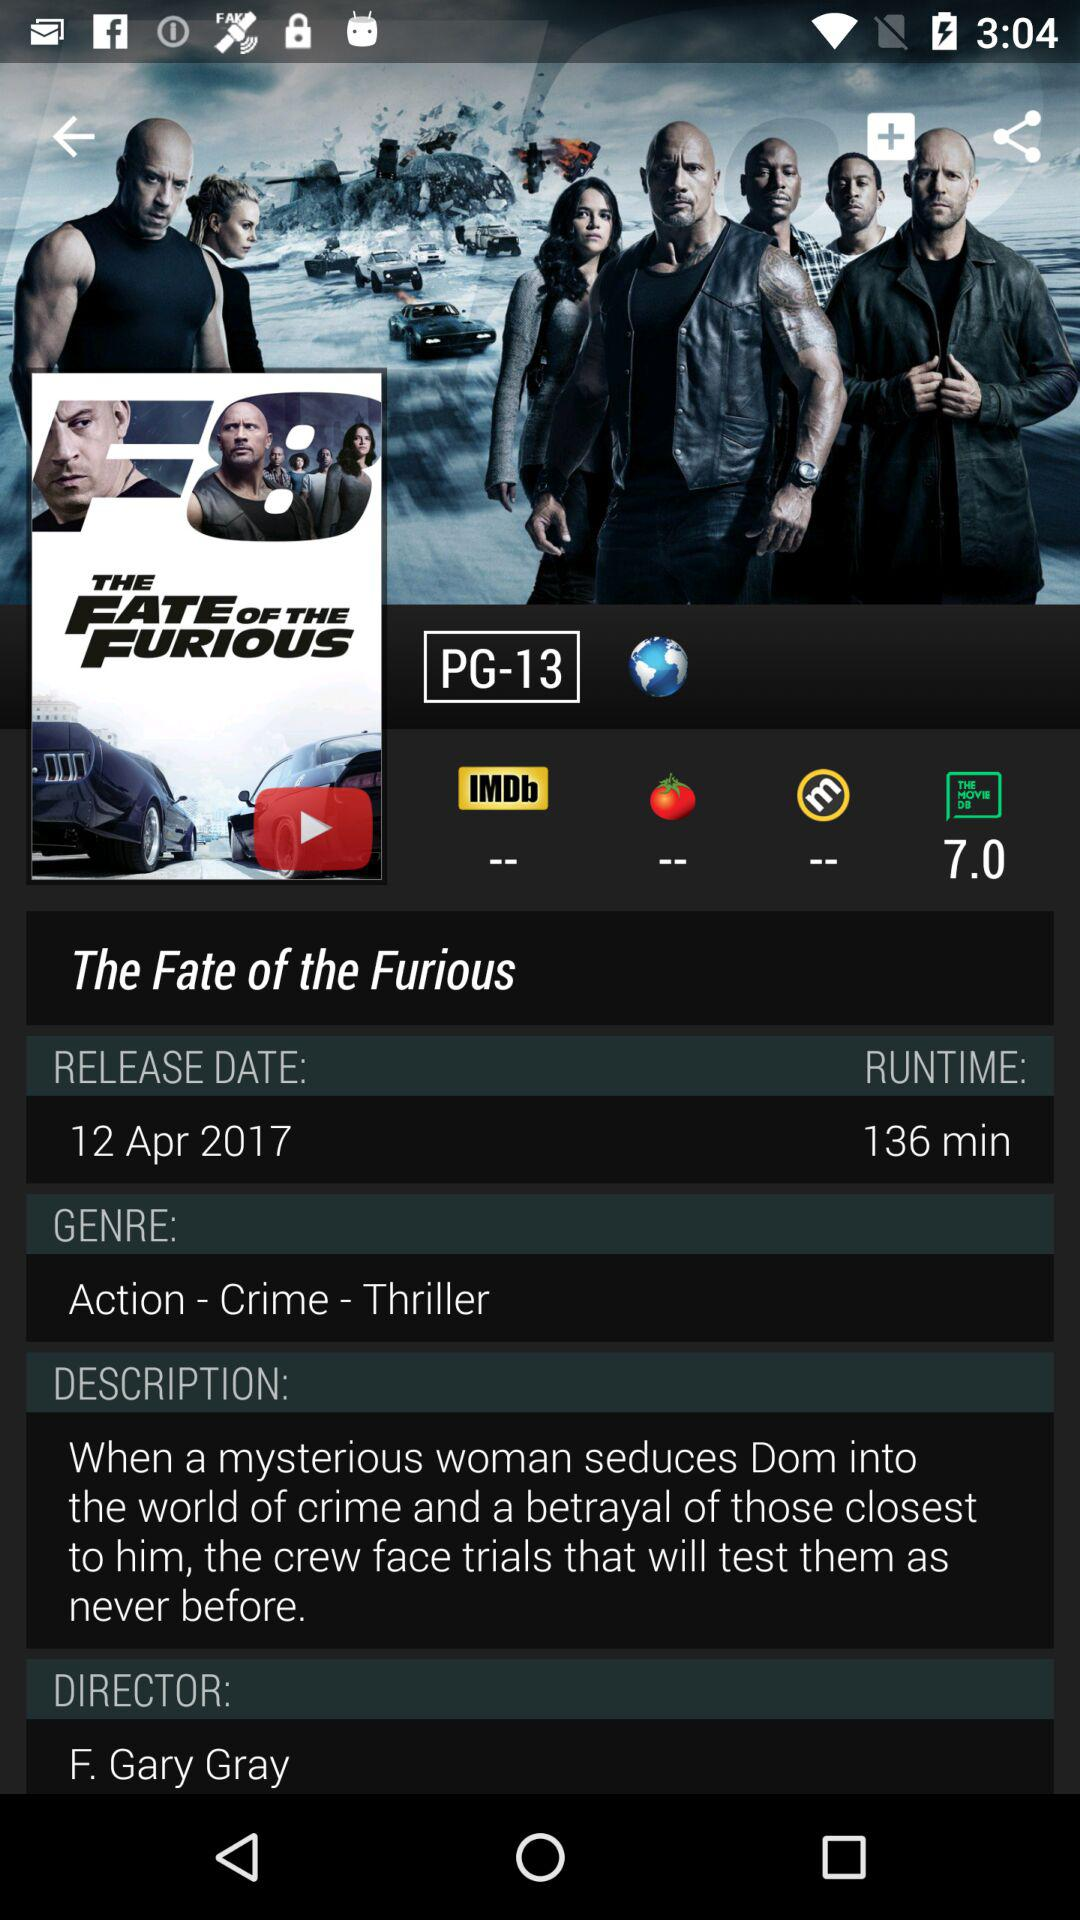What's the movie name? The movie name is "The Fate of the Furious". 